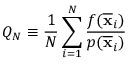Convert formula to latex. <formula><loc_0><loc_0><loc_500><loc_500>Q _ { N } \equiv \frac { 1 } { N } \sum _ { i = 1 } ^ { N } { \frac { f ( { \overline { x } } _ { i } ) } { p ( { \overline { x } } _ { i } ) } }</formula> 